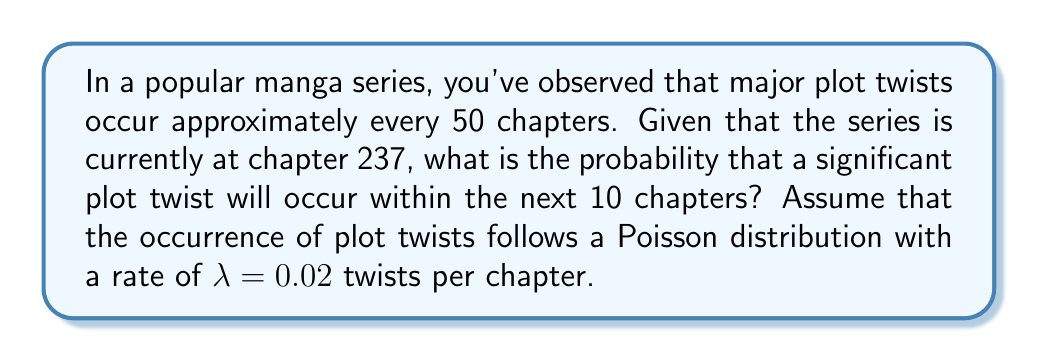What is the answer to this math problem? To solve this problem, we need to use the Poisson distribution, which models the number of events occurring in a fixed interval of time or space. In this case, we're looking at the number of plot twists occurring in a given number of chapters.

Given:
- λ (lambda) = 0.02 twists per chapter
- We want to find the probability of at least one twist in the next 10 chapters

Step 1: Calculate the expected number of twists in 10 chapters.
$$\text{Expected twists} = \lambda \times \text{number of chapters} = 0.02 \times 10 = 0.2$$

Step 2: Use the Poisson distribution to calculate the probability of exactly 0 twists in 10 chapters.
$$P(X = k) = \frac{e^{-\lambda t}(\lambda t)^k}{k!}$$
Where:
- $e$ is Euler's number (approximately 2.71828)
- $\lambda t$ is the expected number of occurrences (0.2 in this case)
- $k$ is the number of occurrences we're calculating (0 in this case)

$$P(X = 0) = \frac{e^{-0.2}(0.2)^0}{0!} = e^{-0.2} \approx 0.8187$$

Step 3: The probability of at least one twist is the complement of the probability of no twists.
$$P(\text{at least one twist}) = 1 - P(\text{no twists}) = 1 - 0.8187 \approx 0.1813$$

Therefore, the probability of a significant plot twist occurring within the next 10 chapters is approximately 0.1813 or 18.13%.
Answer: 0.1813 or 18.13% 